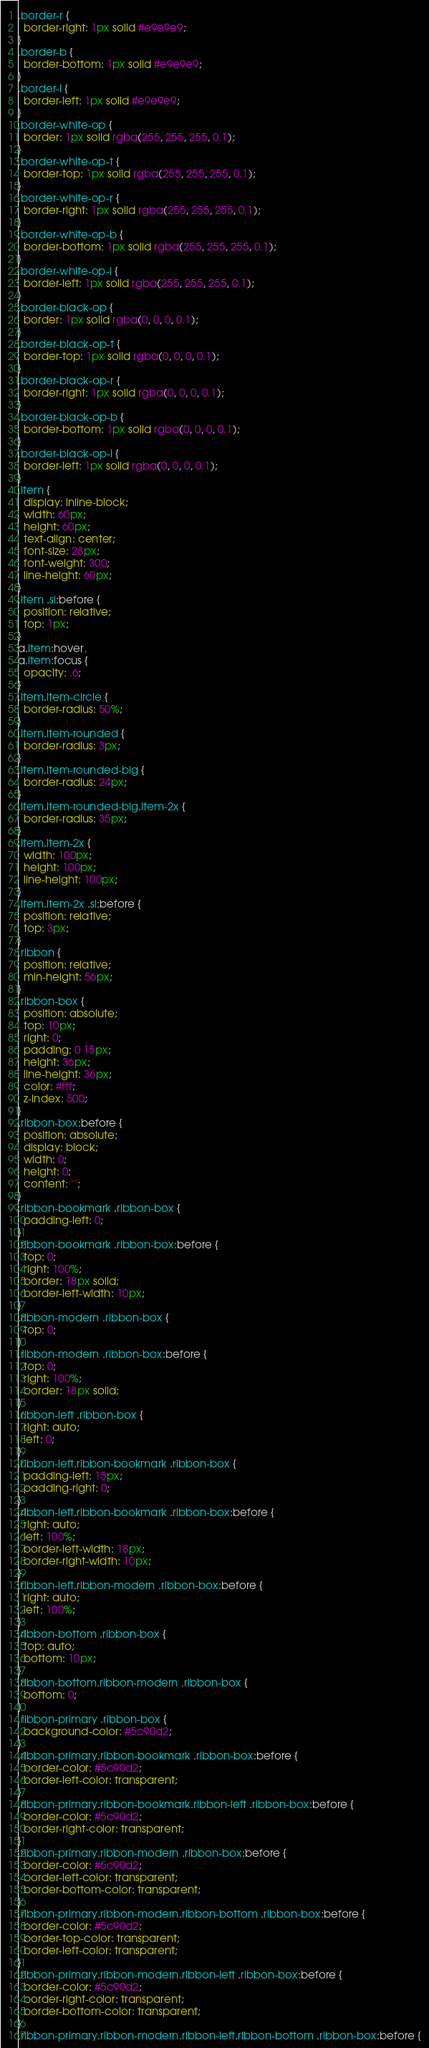<code> <loc_0><loc_0><loc_500><loc_500><_CSS_>.border-r {
  border-right: 1px solid #e9e9e9;
}
.border-b {
  border-bottom: 1px solid #e9e9e9;
}
.border-l {
  border-left: 1px solid #e9e9e9;
}
.border-white-op {
  border: 1px solid rgba(255, 255, 255, 0.1);
}
.border-white-op-t {
  border-top: 1px solid rgba(255, 255, 255, 0.1);
}
.border-white-op-r {
  border-right: 1px solid rgba(255, 255, 255, 0.1);
}
.border-white-op-b {
  border-bottom: 1px solid rgba(255, 255, 255, 0.1);
}
.border-white-op-l {
  border-left: 1px solid rgba(255, 255, 255, 0.1);
}
.border-black-op {
  border: 1px solid rgba(0, 0, 0, 0.1);
}
.border-black-op-t {
  border-top: 1px solid rgba(0, 0, 0, 0.1);
}
.border-black-op-r {
  border-right: 1px solid rgba(0, 0, 0, 0.1);
}
.border-black-op-b {
  border-bottom: 1px solid rgba(0, 0, 0, 0.1);
}
.border-black-op-l {
  border-left: 1px solid rgba(0, 0, 0, 0.1);
}
.item {
  display: inline-block;
  width: 60px;
  height: 60px;
  text-align: center;
  font-size: 28px;
  font-weight: 300;
  line-height: 60px;
}
.item .si:before {
  position: relative;
  top: 1px;
}
a.item:hover,
a.item:focus {
  opacity: .6;
}
.item.item-circle {
  border-radius: 50%;
}
.item.item-rounded {
  border-radius: 3px;
}
.item.item-rounded-big {
  border-radius: 24px;
}
.item.item-rounded-big.item-2x {
  border-radius: 35px;
}
.item.item-2x {
  width: 100px;
  height: 100px;
  line-height: 100px;
}
.item.item-2x .si:before {
  position: relative;
  top: 3px;
}
.ribbon {
  position: relative;
  min-height: 56px;
}
.ribbon-box {
  position: absolute;
  top: 10px;
  right: 0;
  padding: 0 15px;
  height: 36px;
  line-height: 36px;
  color: #fff;
  z-index: 500;
}
.ribbon-box:before {
  position: absolute;
  display: block;
  width: 0;
  height: 0;
  content: "";
}
.ribbon-bookmark .ribbon-box {
  padding-left: 0;
}
.ribbon-bookmark .ribbon-box:before {
  top: 0;
  right: 100%;
  border: 18px solid;
  border-left-width: 10px;
}
.ribbon-modern .ribbon-box {
  top: 0;
}
.ribbon-modern .ribbon-box:before {
  top: 0;
  right: 100%;
  border: 18px solid;
}
.ribbon-left .ribbon-box {
  right: auto;
  left: 0;
}
.ribbon-left.ribbon-bookmark .ribbon-box {
  padding-left: 15px;
  padding-right: 0;
}
.ribbon-left.ribbon-bookmark .ribbon-box:before {
  right: auto;
  left: 100%;
  border-left-width: 18px;
  border-right-width: 10px;
}
.ribbon-left.ribbon-modern .ribbon-box:before {
  right: auto;
  left: 100%;
}
.ribbon-bottom .ribbon-box {
  top: auto;
  bottom: 10px;
}
.ribbon-bottom.ribbon-modern .ribbon-box {
  bottom: 0;
}
.ribbon-primary .ribbon-box {
  background-color: #5c90d2;
}
.ribbon-primary.ribbon-bookmark .ribbon-box:before {
  border-color: #5c90d2;
  border-left-color: transparent;
}
.ribbon-primary.ribbon-bookmark.ribbon-left .ribbon-box:before {
  border-color: #5c90d2;
  border-right-color: transparent;
}
.ribbon-primary.ribbon-modern .ribbon-box:before {
  border-color: #5c90d2;
  border-left-color: transparent;
  border-bottom-color: transparent;
}
.ribbon-primary.ribbon-modern.ribbon-bottom .ribbon-box:before {
  border-color: #5c90d2;
  border-top-color: transparent;
  border-left-color: transparent;
}
.ribbon-primary.ribbon-modern.ribbon-left .ribbon-box:before {
  border-color: #5c90d2;
  border-right-color: transparent;
  border-bottom-color: transparent;
}
.ribbon-primary.ribbon-modern.ribbon-left.ribbon-bottom .ribbon-box:before {</code> 